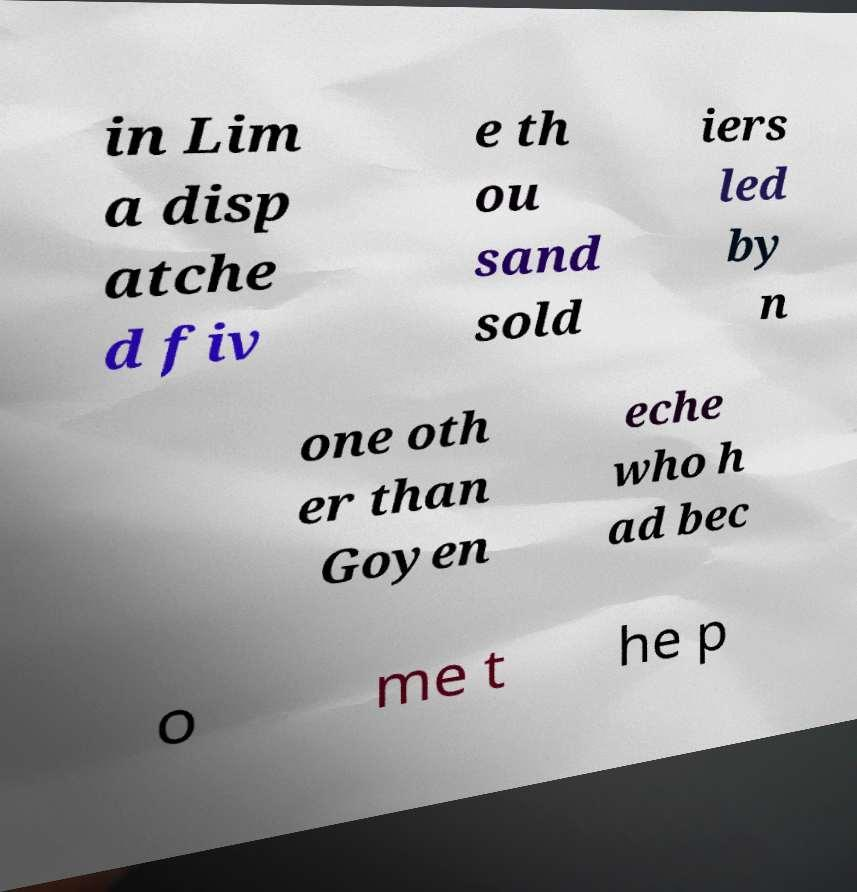Can you accurately transcribe the text from the provided image for me? in Lim a disp atche d fiv e th ou sand sold iers led by n one oth er than Goyen eche who h ad bec o me t he p 